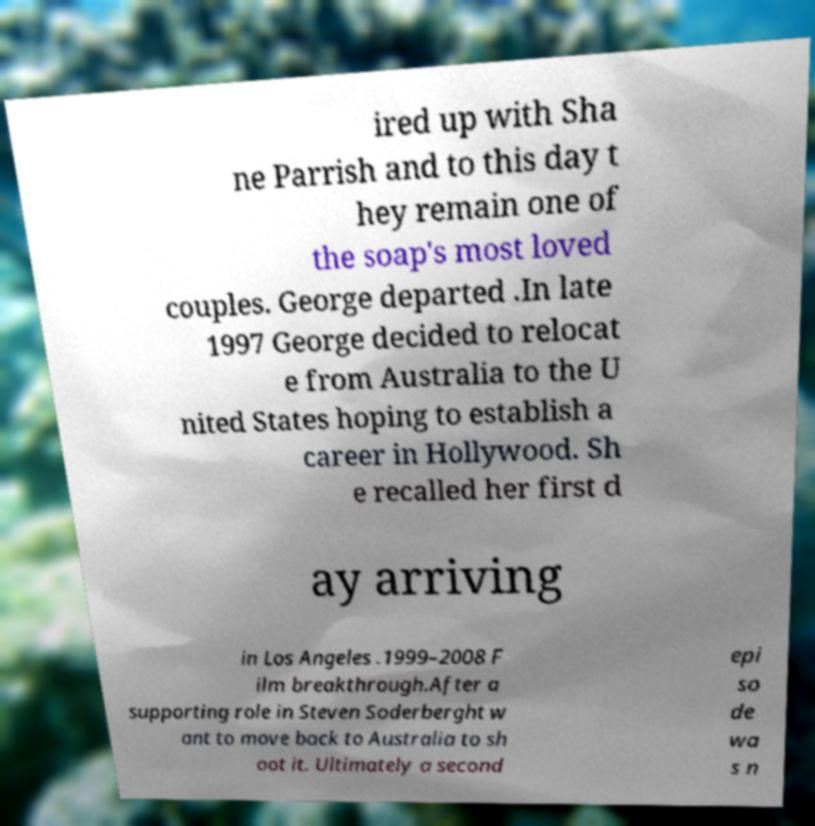There's text embedded in this image that I need extracted. Can you transcribe it verbatim? ired up with Sha ne Parrish and to this day t hey remain one of the soap's most loved couples. George departed .In late 1997 George decided to relocat e from Australia to the U nited States hoping to establish a career in Hollywood. Sh e recalled her first d ay arriving in Los Angeles .1999–2008 F ilm breakthrough.After a supporting role in Steven Soderberght w ant to move back to Australia to sh oot it. Ultimately a second epi so de wa s n 